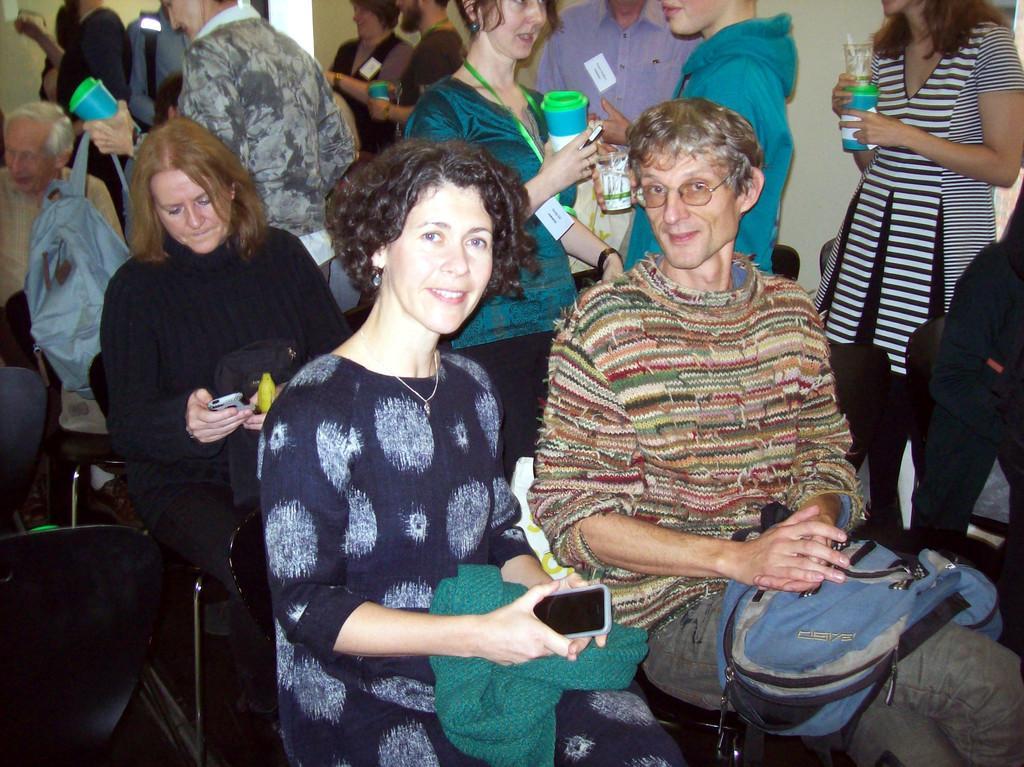Could you give a brief overview of what you see in this image? In this image we can see few people in a room and some of them are sitting and some of them are standing, some of them are holding bottles and some of them are holding cell phones, a person is holding a backpack. 